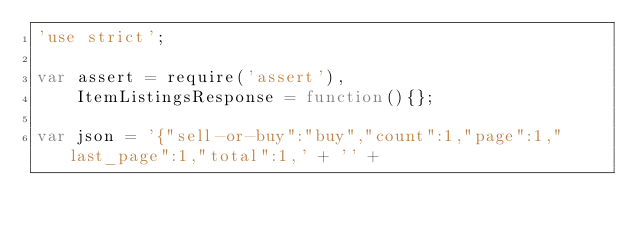<code> <loc_0><loc_0><loc_500><loc_500><_JavaScript_>'use strict';

var assert = require('assert'),
    ItemListingsResponse = function(){};

var json = '{"sell-or-buy":"buy","count":1,"page":1,"last_page":1,"total":1,' + '' +</code> 